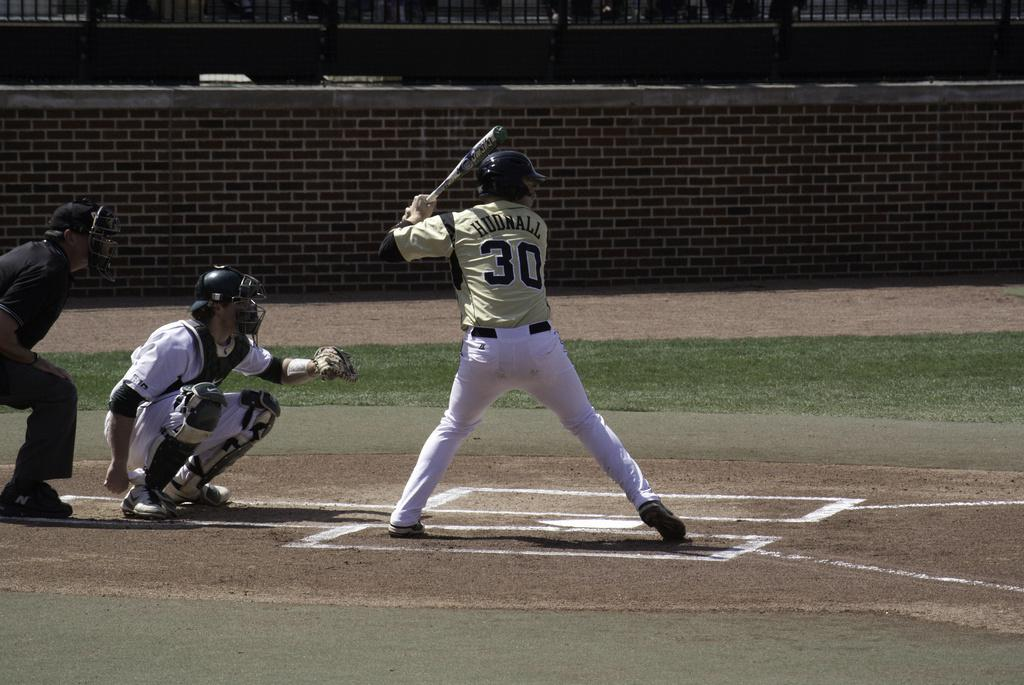What sport are the players engaged in, as seen in the image? The players are playing baseball in the image. Where are the players situated? The players are on a ground. What protective gear are the players wearing? The players are wearing helmets. What equipment do the players have in their hands? The players are holding bats in their hands. What can be seen in the background of the image? There is a wall in the background of the image. Can you tell me how many donkeys are present in the image? There are no donkeys present in the image; the players are playing baseball. What type of engine can be seen powering the players' movements in the image? There is no engine present in the image; the players are using their own physical abilities to play baseball. 